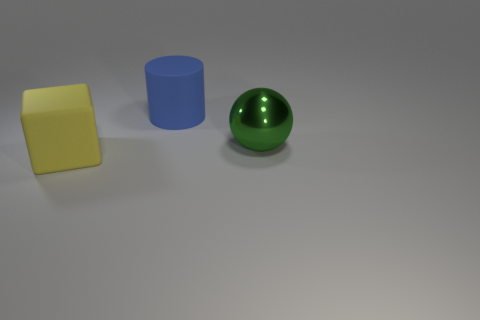Add 3 big blocks. How many objects exist? 6 Subtract all balls. How many objects are left? 2 Subtract 0 cyan cylinders. How many objects are left? 3 Subtract all gray cubes. Subtract all yellow cylinders. How many cubes are left? 1 Subtract all big metallic spheres. Subtract all green spheres. How many objects are left? 1 Add 3 yellow blocks. How many yellow blocks are left? 4 Add 1 big yellow things. How many big yellow things exist? 2 